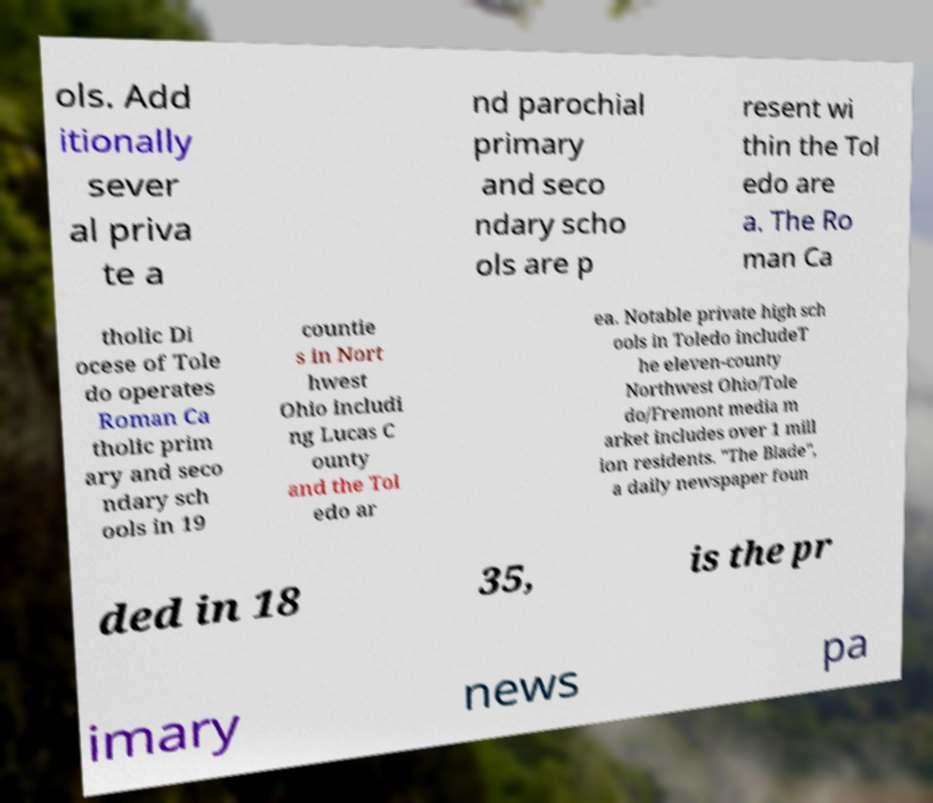Please identify and transcribe the text found in this image. ols. Add itionally sever al priva te a nd parochial primary and seco ndary scho ols are p resent wi thin the Tol edo are a. The Ro man Ca tholic Di ocese of Tole do operates Roman Ca tholic prim ary and seco ndary sch ools in 19 countie s in Nort hwest Ohio includi ng Lucas C ounty and the Tol edo ar ea. Notable private high sch ools in Toledo includeT he eleven-county Northwest Ohio/Tole do/Fremont media m arket includes over 1 mill ion residents. "The Blade", a daily newspaper foun ded in 18 35, is the pr imary news pa 